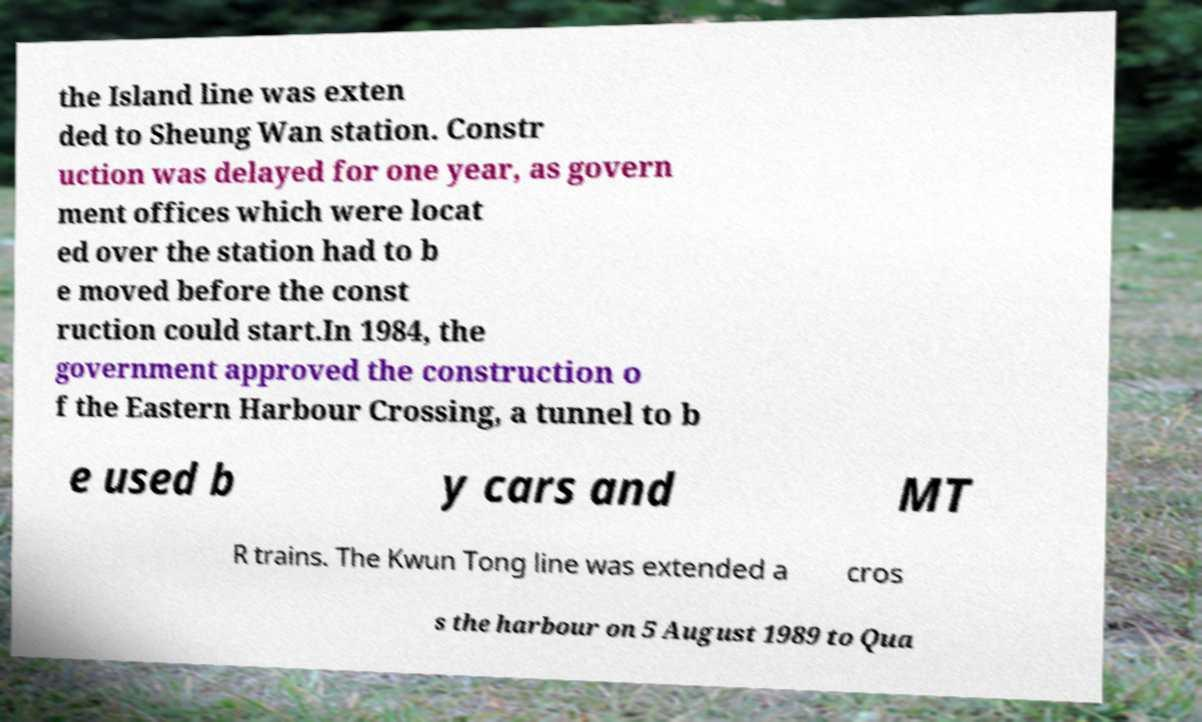Can you read and provide the text displayed in the image?This photo seems to have some interesting text. Can you extract and type it out for me? the Island line was exten ded to Sheung Wan station. Constr uction was delayed for one year, as govern ment offices which were locat ed over the station had to b e moved before the const ruction could start.In 1984, the government approved the construction o f the Eastern Harbour Crossing, a tunnel to b e used b y cars and MT R trains. The Kwun Tong line was extended a cros s the harbour on 5 August 1989 to Qua 